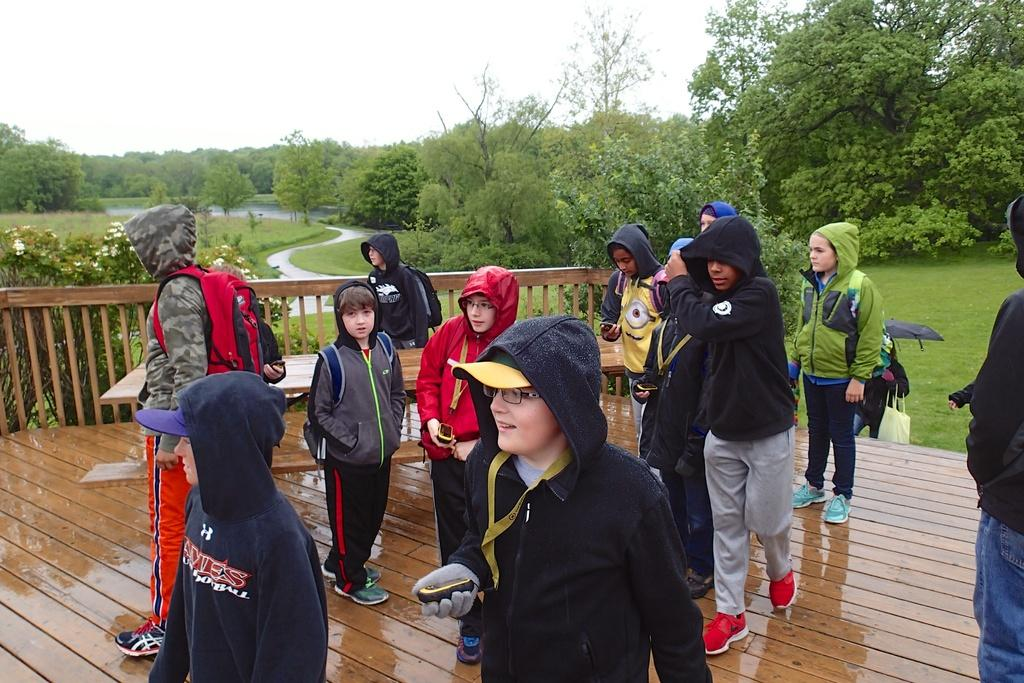How many people are in the group in the image? There is a group of people in the image, but the exact number cannot be determined from the provided facts. What are some people in the group wearing? Some people in the group are wearing caps. What can be seen in the background of the image? There is grass, trees, and water visible in the background of the image. What is located on the left side of the image? There are flowers on the left side of the image. What type of silver object can be seen in the hands of the person wearing a red cap in the image? There is no silver object visible in the image, and no person is described as wearing a red cap. 